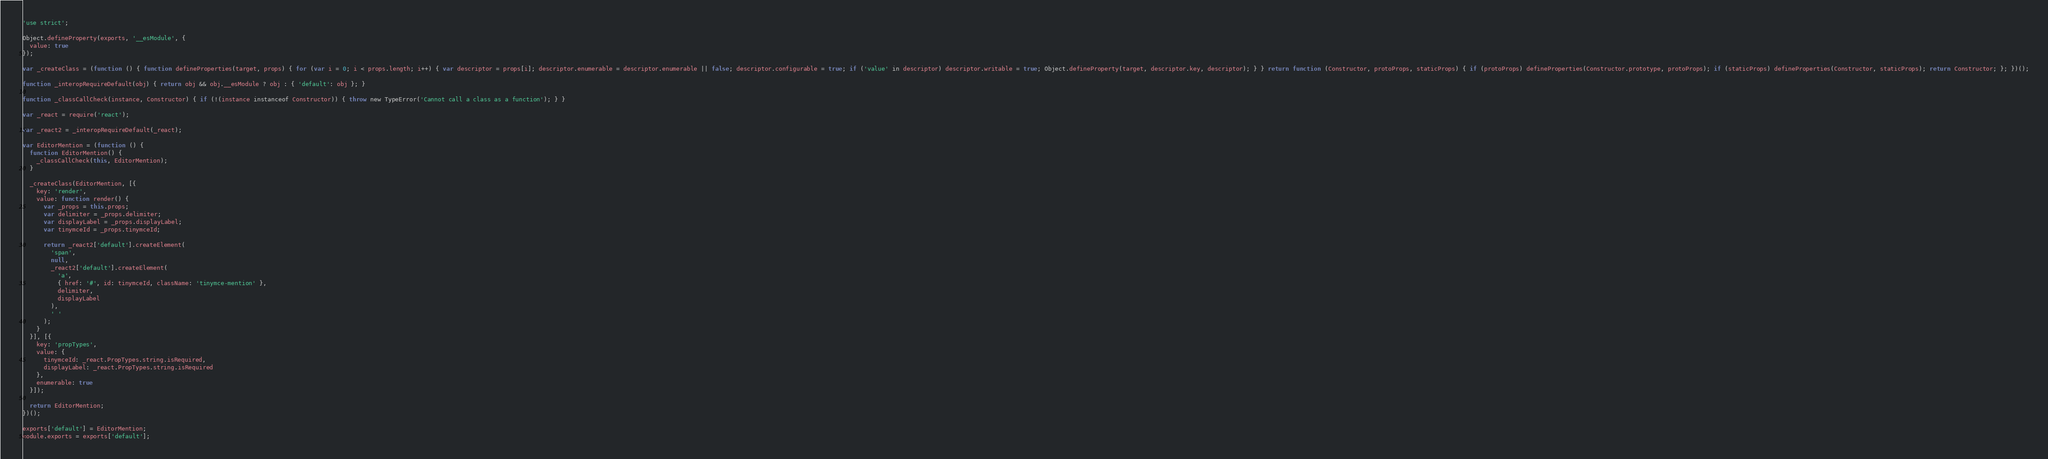Convert code to text. <code><loc_0><loc_0><loc_500><loc_500><_JavaScript_>'use strict';

Object.defineProperty(exports, '__esModule', {
  value: true
});

var _createClass = (function () { function defineProperties(target, props) { for (var i = 0; i < props.length; i++) { var descriptor = props[i]; descriptor.enumerable = descriptor.enumerable || false; descriptor.configurable = true; if ('value' in descriptor) descriptor.writable = true; Object.defineProperty(target, descriptor.key, descriptor); } } return function (Constructor, protoProps, staticProps) { if (protoProps) defineProperties(Constructor.prototype, protoProps); if (staticProps) defineProperties(Constructor, staticProps); return Constructor; }; })();

function _interopRequireDefault(obj) { return obj && obj.__esModule ? obj : { 'default': obj }; }

function _classCallCheck(instance, Constructor) { if (!(instance instanceof Constructor)) { throw new TypeError('Cannot call a class as a function'); } }

var _react = require('react');

var _react2 = _interopRequireDefault(_react);

var EditorMention = (function () {
  function EditorMention() {
    _classCallCheck(this, EditorMention);
  }

  _createClass(EditorMention, [{
    key: 'render',
    value: function render() {
      var _props = this.props;
      var delimiter = _props.delimiter;
      var displayLabel = _props.displayLabel;
      var tinymceId = _props.tinymceId;

      return _react2['default'].createElement(
        'span',
        null,
        _react2['default'].createElement(
          'a',
          { href: '#', id: tinymceId, className: 'tinymce-mention' },
          delimiter,
          displayLabel
        ),
        ' '
      );
    }
  }], [{
    key: 'propTypes',
    value: {
      tinymceId: _react.PropTypes.string.isRequired,
      displayLabel: _react.PropTypes.string.isRequired
    },
    enumerable: true
  }]);

  return EditorMention;
})();

exports['default'] = EditorMention;
module.exports = exports['default'];</code> 